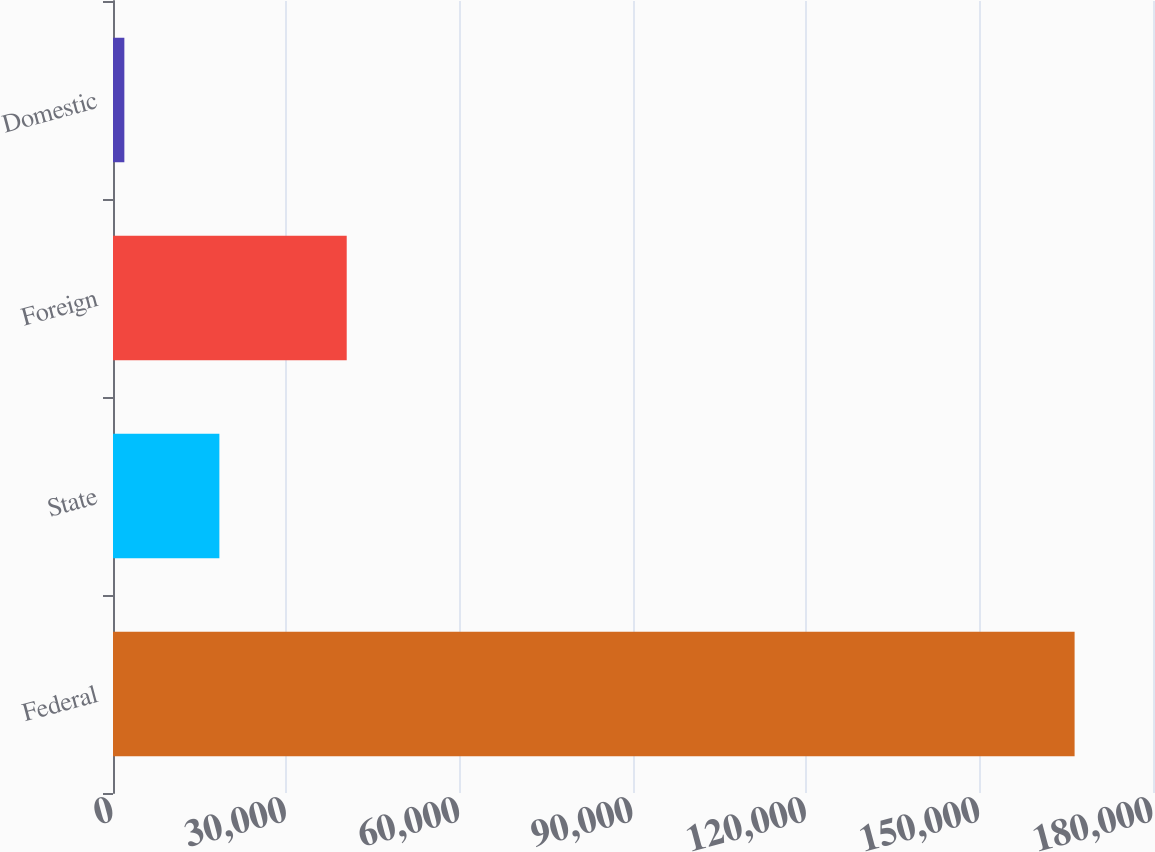Convert chart. <chart><loc_0><loc_0><loc_500><loc_500><bar_chart><fcel>Federal<fcel>State<fcel>Foreign<fcel>Domestic<nl><fcel>166430<fcel>18411.5<fcel>40451<fcel>1965<nl></chart> 